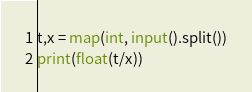<code> <loc_0><loc_0><loc_500><loc_500><_Python_>t,x = map(int, input().split())
print(float(t/x))</code> 